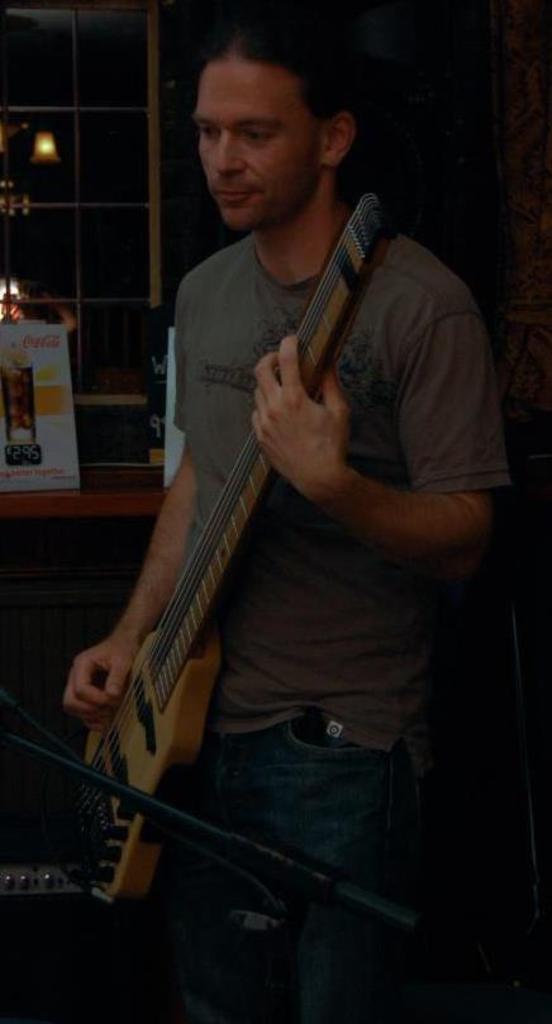Describe this image in one or two sentences. In this image there is a person standing and playing guitar. Beside him there is table and there is a board on it. In the background there is a window and a wall lamp. 